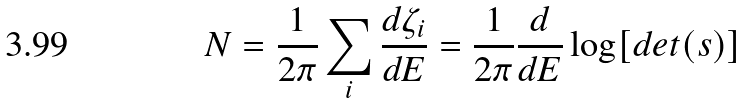<formula> <loc_0><loc_0><loc_500><loc_500>N = \frac { 1 } { 2 \pi } \sum _ { i } \frac { d \zeta _ { i } } { d E } = \frac { 1 } { 2 \pi } \frac { d } { d E } \log [ d e t ( { s } ) ]</formula> 